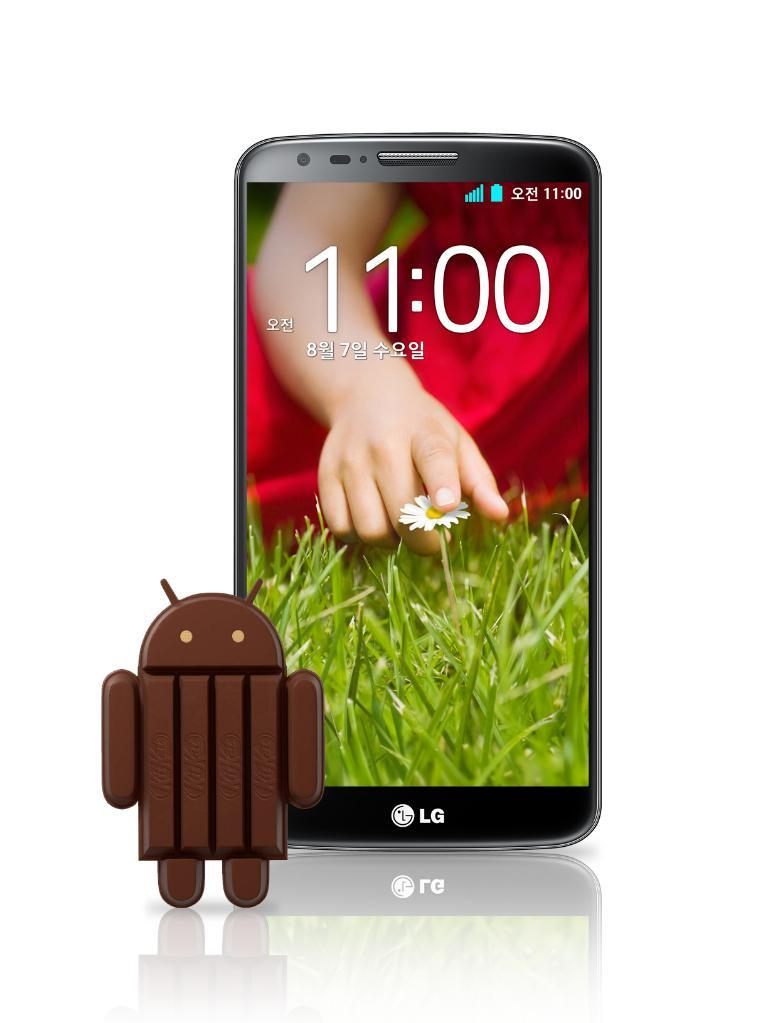What electronic device is present in the image? There is a mobile phone in the image. What is displayed on the mobile phone's screen? The mobile screen displays a person, a flower, and grass. How does the mobile phone help pay off the person's debt in the image? There is no mention of debt in the image, and the mobile phone's screen displays a person, a flower, and grass. What type of umbrella is being used to protect the person on the mobile phone's screen from the rain in the image? There is no umbrella present in the image, and the mobile phone's screen displays a person, a flower, and grass. 